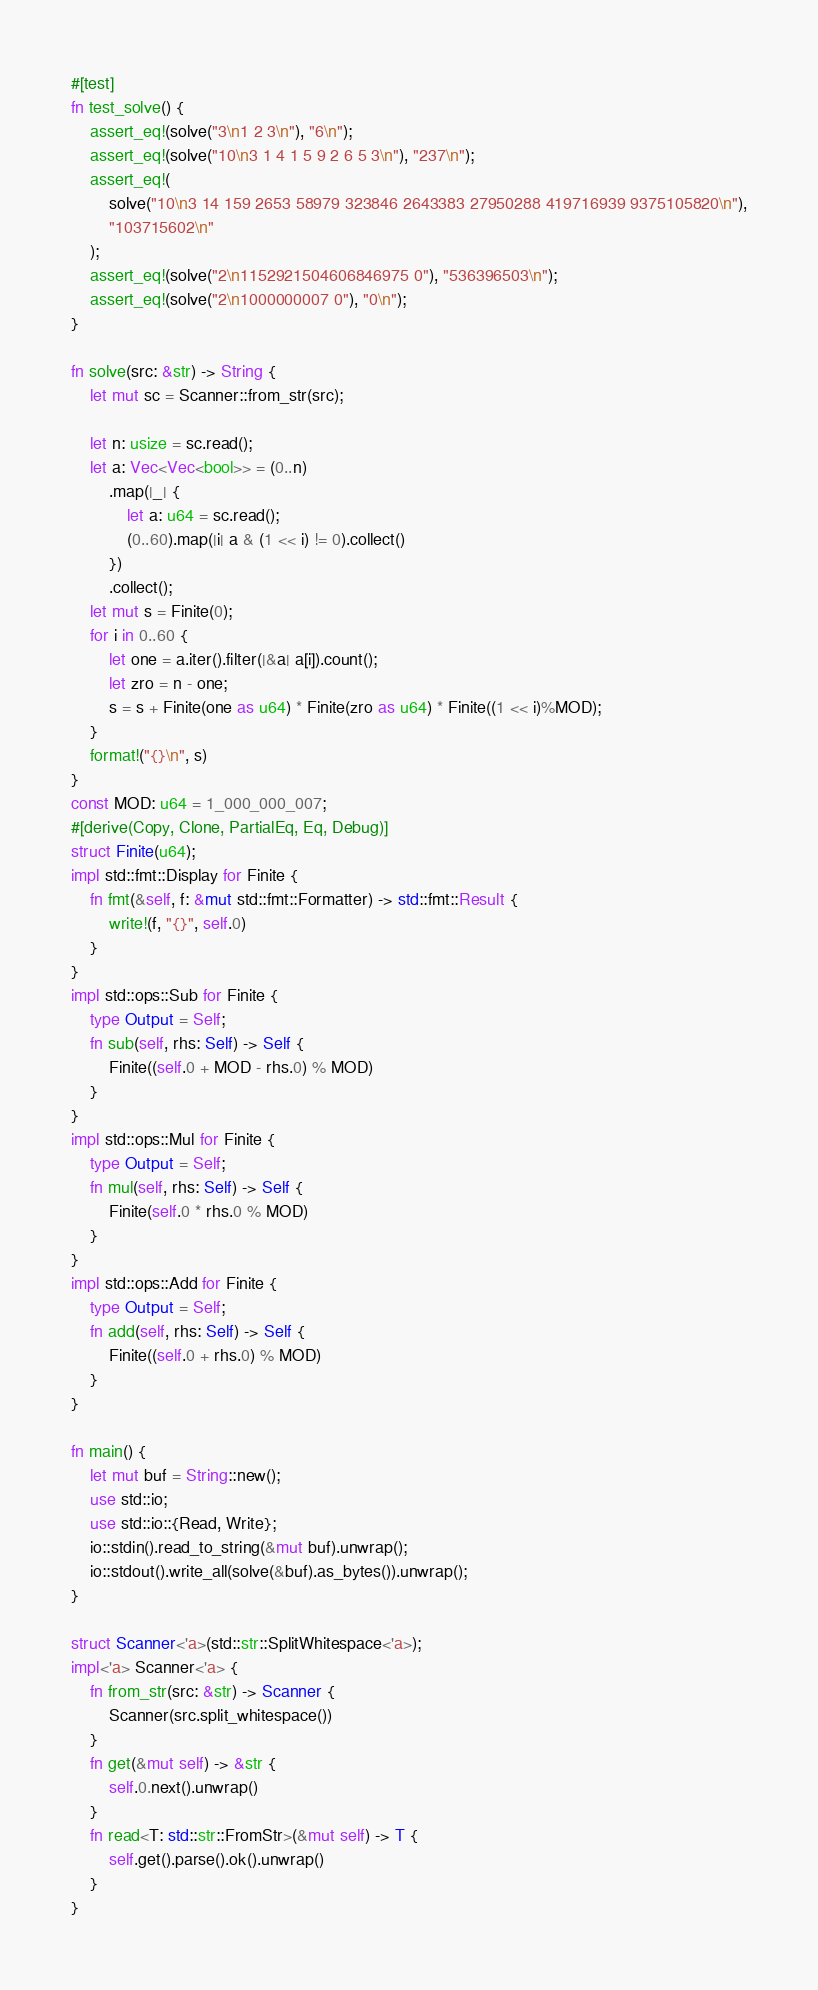<code> <loc_0><loc_0><loc_500><loc_500><_Rust_>#[test]
fn test_solve() {
    assert_eq!(solve("3\n1 2 3\n"), "6\n");
    assert_eq!(solve("10\n3 1 4 1 5 9 2 6 5 3\n"), "237\n");
    assert_eq!(
        solve("10\n3 14 159 2653 58979 323846 2643383 27950288 419716939 9375105820\n"),
        "103715602\n"
    );
    assert_eq!(solve("2\n1152921504606846975 0"), "536396503\n");
    assert_eq!(solve("2\n1000000007 0"), "0\n");
}

fn solve(src: &str) -> String {
    let mut sc = Scanner::from_str(src);

    let n: usize = sc.read();
    let a: Vec<Vec<bool>> = (0..n)
        .map(|_| {
            let a: u64 = sc.read();
            (0..60).map(|i| a & (1 << i) != 0).collect()
        })
        .collect();
    let mut s = Finite(0);
    for i in 0..60 {
        let one = a.iter().filter(|&a| a[i]).count();
        let zro = n - one;
        s = s + Finite(one as u64) * Finite(zro as u64) * Finite((1 << i)%MOD);
    }
    format!("{}\n", s)
}
const MOD: u64 = 1_000_000_007;
#[derive(Copy, Clone, PartialEq, Eq, Debug)]
struct Finite(u64);
impl std::fmt::Display for Finite {
    fn fmt(&self, f: &mut std::fmt::Formatter) -> std::fmt::Result {
        write!(f, "{}", self.0)
    }
}
impl std::ops::Sub for Finite {
    type Output = Self;
    fn sub(self, rhs: Self) -> Self {
        Finite((self.0 + MOD - rhs.0) % MOD)
    }
}
impl std::ops::Mul for Finite {
    type Output = Self;
    fn mul(self, rhs: Self) -> Self {
        Finite(self.0 * rhs.0 % MOD)
    }
}
impl std::ops::Add for Finite {
    type Output = Self;
    fn add(self, rhs: Self) -> Self {
        Finite((self.0 + rhs.0) % MOD)
    }
}

fn main() {
    let mut buf = String::new();
    use std::io;
    use std::io::{Read, Write};
    io::stdin().read_to_string(&mut buf).unwrap();
    io::stdout().write_all(solve(&buf).as_bytes()).unwrap();
}

struct Scanner<'a>(std::str::SplitWhitespace<'a>);
impl<'a> Scanner<'a> {
    fn from_str(src: &str) -> Scanner {
        Scanner(src.split_whitespace())
    }
    fn get(&mut self) -> &str {
        self.0.next().unwrap()
    }
    fn read<T: std::str::FromStr>(&mut self) -> T {
        self.get().parse().ok().unwrap()
    }
}
</code> 